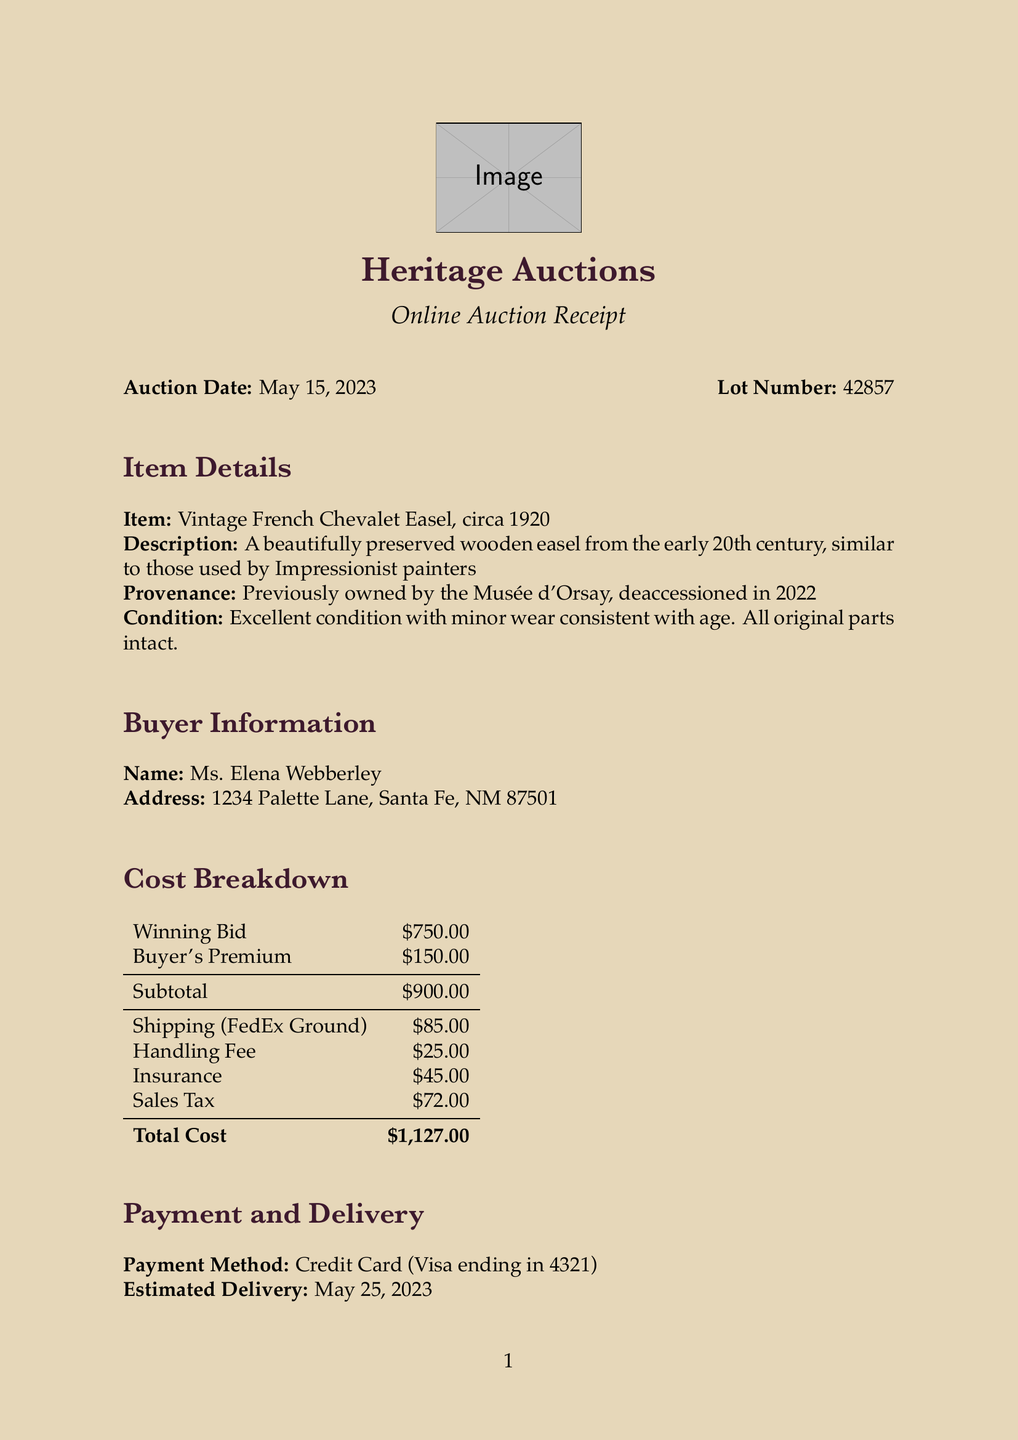What is the auction date? The auction date is specified in the document, which states May 15, 2023.
Answer: May 15, 2023 What is the buyer's name? The buyer's name is mentioned under Buyer Information in the document as Ms. Elena Webberley.
Answer: Ms. Elena Webberley What is the winning bid amount? The document identifies the winning bid amount as part of the Cost Breakdown section, listed as $750.00.
Answer: $750.00 What is the total cost of the easel? The total cost is calculated at the end of the Cost Breakdown section, showing $1,127.00.
Answer: $1,127.00 What is the estimated delivery date? The estimated delivery date is noted in the Payment and Delivery section as May 25, 2023.
Answer: May 25, 2023 What shipping method was used? The shipping method is itemized in the Cost Breakdown section as FedEx Ground.
Answer: FedEx Ground How much was the handling fee? The handling fee is listed in the document under the Cost Breakdown section as $25.00.
Answer: $25.00 What special instructions were provided? The document details special instructions about handling care because of artistic preservation in the Special Instructions section.
Answer: Please handle with care Who is the auction house representative? The document mentions Sarah Thompson as the auction house representative in the Contact Information section.
Answer: Sarah Thompson 